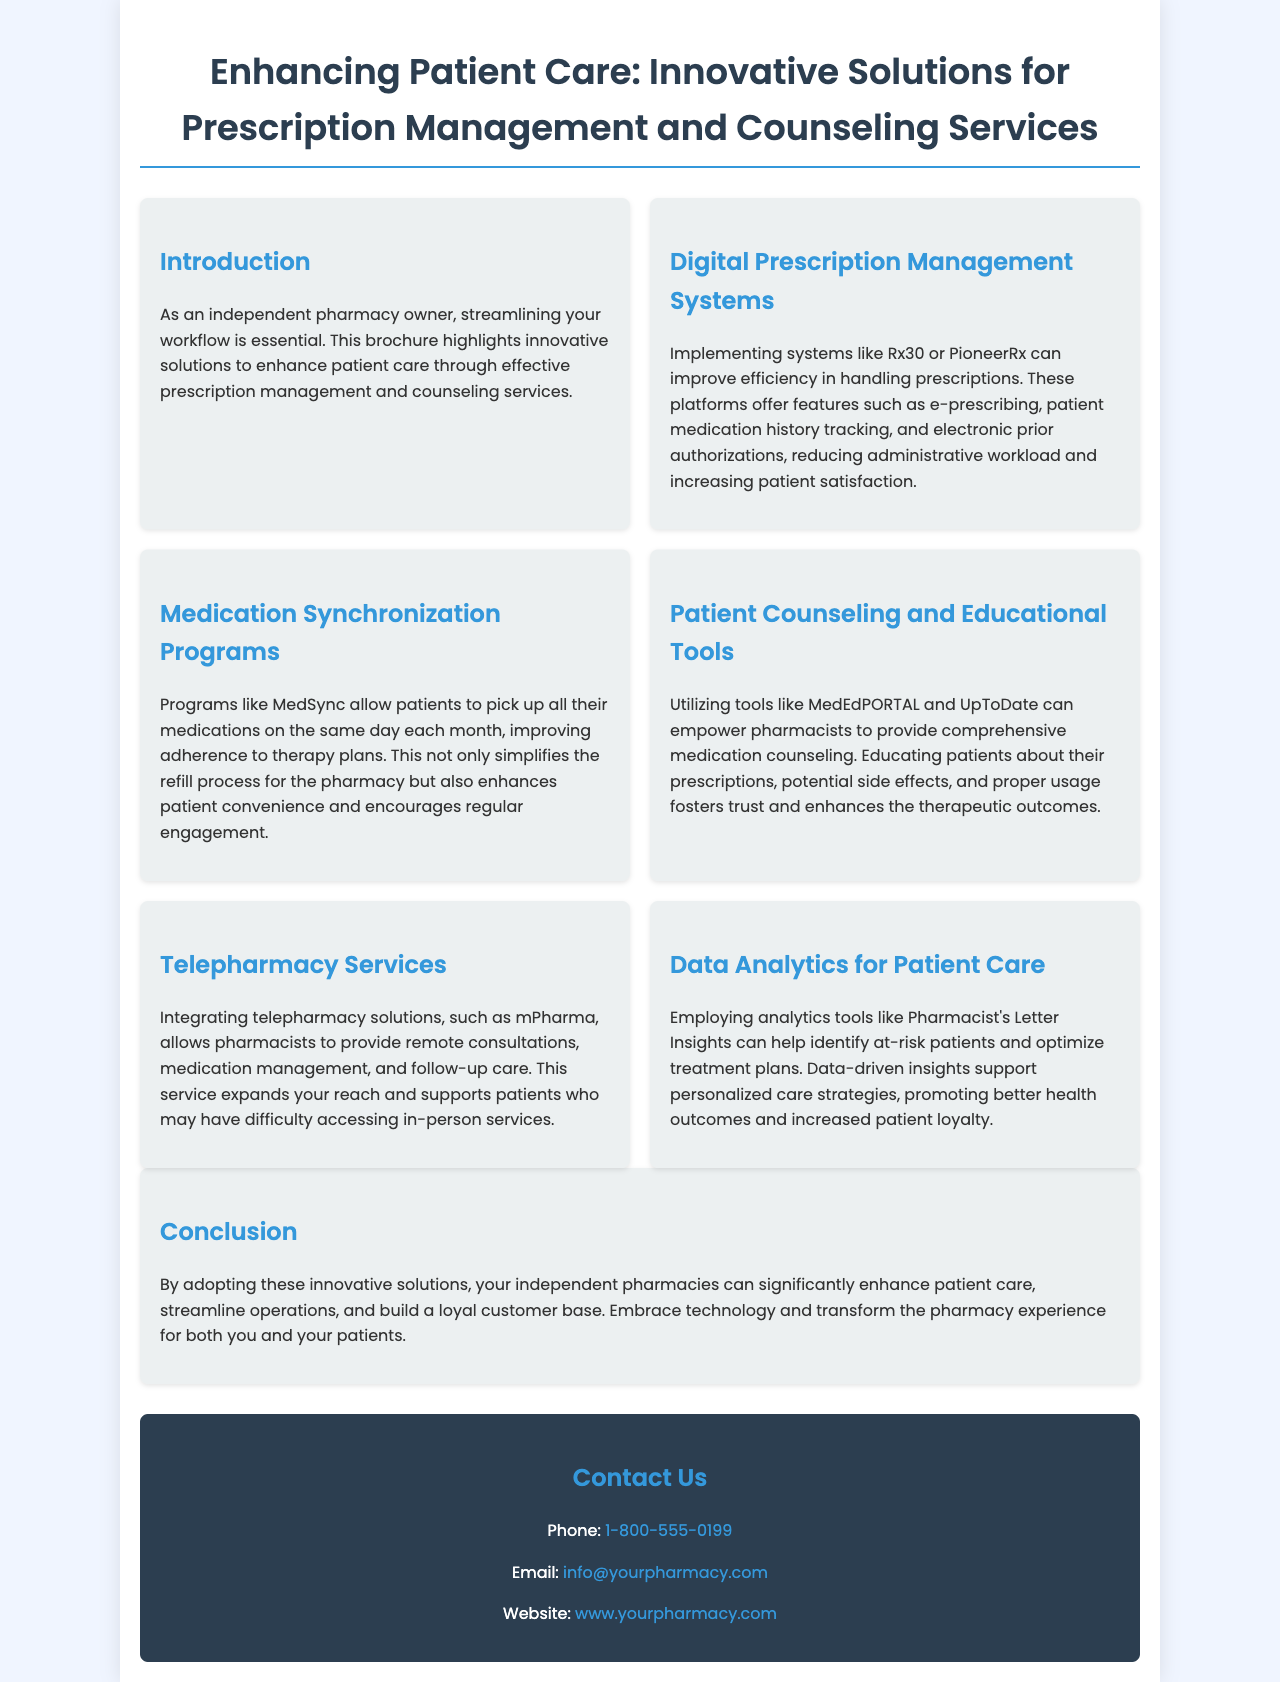What is the title of the brochure? The title of the brochure is stated at the beginning and provides the main focus of the content.
Answer: Enhancing Patient Care: Innovative Solutions for Prescription Management and Counseling Services What system is mentioned for digital prescription management? The document lists specific systems that can improve prescription management efficiency.
Answer: Rx30 or PioneerRx What programs help improve medication adherence? The brochure refers to specific programs designed to help patients manage their medications better.
Answer: MedSync What tool is suggested for patient education by pharmacists? The document mentions tools that pharmacists can use to provide patients with educational resources.
Answer: MedEdPORTAL and UpToDate How can telepharmacy expand pharmacy services? The brochure describes how telepharmacy services can enhance patient access to consultations.
Answer: Remote consultations What analytics tool is highlighted for optimizing treatment plans? The document identifies a specific analytics tool that aids pharmacists in patient care.
Answer: Pharmacist's Letter Insights What is the primary benefit of adopting innovative solutions for pharmacies? The brochure concludes with the broad advantages of implementing the recommended strategies.
Answer: Enhance patient care What method is recommended for streamlining workflow? The document emphasizes a specific area that independent pharmacies can improve efficiency.
Answer: Technology 